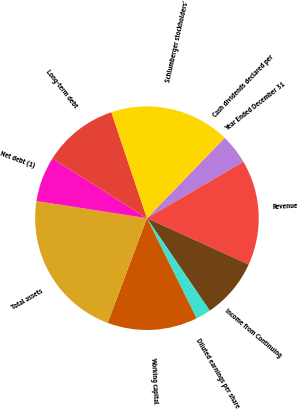<chart> <loc_0><loc_0><loc_500><loc_500><pie_chart><fcel>Year Ended December 31<fcel>Revenue<fcel>Income from Continuing<fcel>Diluted earnings per share<fcel>Working capital<fcel>Total assets<fcel>Net debt (1)<fcel>Long-term debt<fcel>Schlumberger stockholders'<fcel>Cash dividends declared per<nl><fcel>4.35%<fcel>15.22%<fcel>8.7%<fcel>2.17%<fcel>13.04%<fcel>21.74%<fcel>6.52%<fcel>10.87%<fcel>17.39%<fcel>0.0%<nl></chart> 